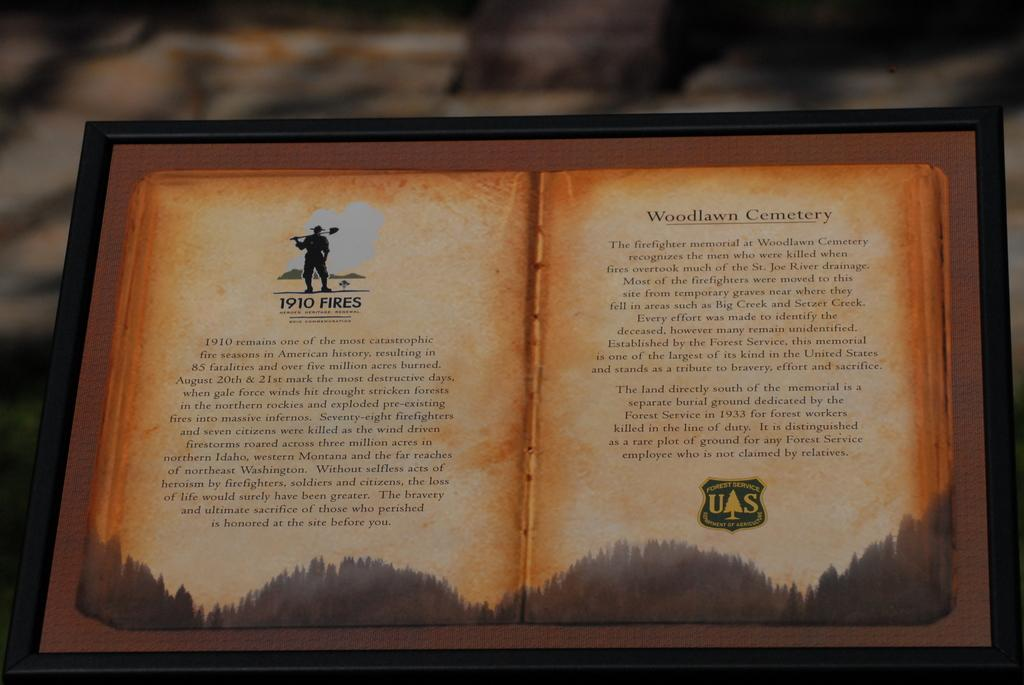<image>
Describe the image concisely. A book is open to a page about Woodlawn Cemetery. 